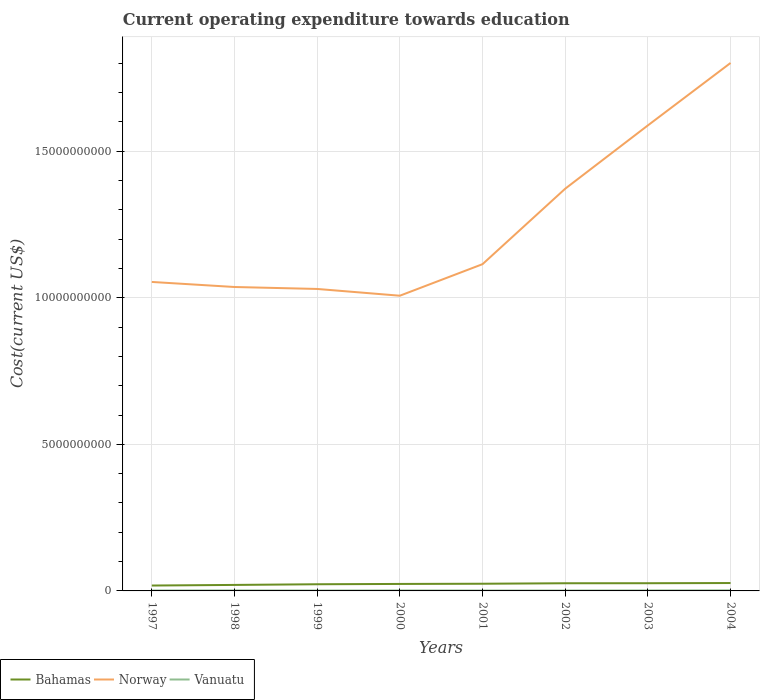Across all years, what is the maximum expenditure towards education in Norway?
Make the answer very short. 1.01e+1. In which year was the expenditure towards education in Bahamas maximum?
Offer a very short reply. 1997. What is the total expenditure towards education in Bahamas in the graph?
Ensure brevity in your answer.  -5.47e+07. What is the difference between the highest and the second highest expenditure towards education in Vanuatu?
Offer a terse response. 5.48e+06. Is the expenditure towards education in Bahamas strictly greater than the expenditure towards education in Norway over the years?
Your answer should be very brief. Yes. How many years are there in the graph?
Your answer should be compact. 8. Does the graph contain grids?
Your answer should be compact. Yes. Where does the legend appear in the graph?
Give a very brief answer. Bottom left. How many legend labels are there?
Make the answer very short. 3. What is the title of the graph?
Give a very brief answer. Current operating expenditure towards education. Does "Mali" appear as one of the legend labels in the graph?
Keep it short and to the point. No. What is the label or title of the Y-axis?
Ensure brevity in your answer.  Cost(current US$). What is the Cost(current US$) in Bahamas in 1997?
Your response must be concise. 1.84e+08. What is the Cost(current US$) in Norway in 1997?
Keep it short and to the point. 1.05e+1. What is the Cost(current US$) of Vanuatu in 1997?
Your answer should be very brief. 1.43e+07. What is the Cost(current US$) of Bahamas in 1998?
Provide a succinct answer. 2.04e+08. What is the Cost(current US$) in Norway in 1998?
Give a very brief answer. 1.04e+1. What is the Cost(current US$) in Vanuatu in 1998?
Keep it short and to the point. 1.70e+07. What is the Cost(current US$) of Bahamas in 1999?
Offer a terse response. 2.27e+08. What is the Cost(current US$) of Norway in 1999?
Offer a terse response. 1.03e+1. What is the Cost(current US$) of Vanuatu in 1999?
Your response must be concise. 1.39e+07. What is the Cost(current US$) of Bahamas in 2000?
Your answer should be very brief. 2.38e+08. What is the Cost(current US$) of Norway in 2000?
Ensure brevity in your answer.  1.01e+1. What is the Cost(current US$) of Vanuatu in 2000?
Make the answer very short. 1.58e+07. What is the Cost(current US$) of Bahamas in 2001?
Your response must be concise. 2.45e+08. What is the Cost(current US$) of Norway in 2001?
Provide a short and direct response. 1.11e+1. What is the Cost(current US$) of Vanuatu in 2001?
Give a very brief answer. 1.37e+07. What is the Cost(current US$) of Bahamas in 2002?
Offer a very short reply. 2.62e+08. What is the Cost(current US$) in Norway in 2002?
Offer a very short reply. 1.37e+1. What is the Cost(current US$) in Vanuatu in 2002?
Your answer should be compact. 1.37e+07. What is the Cost(current US$) of Bahamas in 2003?
Provide a succinct answer. 2.63e+08. What is the Cost(current US$) of Norway in 2003?
Offer a very short reply. 1.59e+1. What is the Cost(current US$) of Vanuatu in 2003?
Make the answer very short. 1.64e+07. What is the Cost(current US$) in Bahamas in 2004?
Make the answer very short. 2.69e+08. What is the Cost(current US$) in Norway in 2004?
Provide a short and direct response. 1.80e+1. What is the Cost(current US$) of Vanuatu in 2004?
Your answer should be compact. 1.91e+07. Across all years, what is the maximum Cost(current US$) in Bahamas?
Your response must be concise. 2.69e+08. Across all years, what is the maximum Cost(current US$) of Norway?
Offer a terse response. 1.80e+1. Across all years, what is the maximum Cost(current US$) of Vanuatu?
Ensure brevity in your answer.  1.91e+07. Across all years, what is the minimum Cost(current US$) in Bahamas?
Provide a short and direct response. 1.84e+08. Across all years, what is the minimum Cost(current US$) in Norway?
Provide a succinct answer. 1.01e+1. Across all years, what is the minimum Cost(current US$) in Vanuatu?
Make the answer very short. 1.37e+07. What is the total Cost(current US$) in Bahamas in the graph?
Ensure brevity in your answer.  1.89e+09. What is the total Cost(current US$) of Norway in the graph?
Keep it short and to the point. 1.00e+11. What is the total Cost(current US$) in Vanuatu in the graph?
Give a very brief answer. 1.24e+08. What is the difference between the Cost(current US$) of Bahamas in 1997 and that in 1998?
Provide a short and direct response. -2.07e+07. What is the difference between the Cost(current US$) in Norway in 1997 and that in 1998?
Offer a very short reply. 1.73e+08. What is the difference between the Cost(current US$) in Vanuatu in 1997 and that in 1998?
Ensure brevity in your answer.  -2.72e+06. What is the difference between the Cost(current US$) of Bahamas in 1997 and that in 1999?
Give a very brief answer. -4.37e+07. What is the difference between the Cost(current US$) of Norway in 1997 and that in 1999?
Give a very brief answer. 2.39e+08. What is the difference between the Cost(current US$) in Vanuatu in 1997 and that in 1999?
Your response must be concise. 3.95e+05. What is the difference between the Cost(current US$) in Bahamas in 1997 and that in 2000?
Your answer should be very brief. -5.47e+07. What is the difference between the Cost(current US$) of Norway in 1997 and that in 2000?
Make the answer very short. 4.70e+08. What is the difference between the Cost(current US$) in Vanuatu in 1997 and that in 2000?
Your answer should be very brief. -1.47e+06. What is the difference between the Cost(current US$) in Bahamas in 1997 and that in 2001?
Your answer should be compact. -6.13e+07. What is the difference between the Cost(current US$) of Norway in 1997 and that in 2001?
Your answer should be very brief. -6.06e+08. What is the difference between the Cost(current US$) in Vanuatu in 1997 and that in 2001?
Offer a very short reply. 6.16e+05. What is the difference between the Cost(current US$) of Bahamas in 1997 and that in 2002?
Ensure brevity in your answer.  -7.80e+07. What is the difference between the Cost(current US$) of Norway in 1997 and that in 2002?
Your answer should be compact. -3.18e+09. What is the difference between the Cost(current US$) of Vanuatu in 1997 and that in 2002?
Give a very brief answer. 6.63e+05. What is the difference between the Cost(current US$) in Bahamas in 1997 and that in 2003?
Give a very brief answer. -7.91e+07. What is the difference between the Cost(current US$) in Norway in 1997 and that in 2003?
Give a very brief answer. -5.34e+09. What is the difference between the Cost(current US$) in Vanuatu in 1997 and that in 2003?
Your answer should be very brief. -2.09e+06. What is the difference between the Cost(current US$) of Bahamas in 1997 and that in 2004?
Your response must be concise. -8.54e+07. What is the difference between the Cost(current US$) in Norway in 1997 and that in 2004?
Keep it short and to the point. -7.47e+09. What is the difference between the Cost(current US$) of Vanuatu in 1997 and that in 2004?
Give a very brief answer. -4.82e+06. What is the difference between the Cost(current US$) of Bahamas in 1998 and that in 1999?
Ensure brevity in your answer.  -2.30e+07. What is the difference between the Cost(current US$) in Norway in 1998 and that in 1999?
Make the answer very short. 6.64e+07. What is the difference between the Cost(current US$) of Vanuatu in 1998 and that in 1999?
Offer a very short reply. 3.12e+06. What is the difference between the Cost(current US$) in Bahamas in 1998 and that in 2000?
Give a very brief answer. -3.40e+07. What is the difference between the Cost(current US$) in Norway in 1998 and that in 2000?
Give a very brief answer. 2.97e+08. What is the difference between the Cost(current US$) in Vanuatu in 1998 and that in 2000?
Your answer should be very brief. 1.25e+06. What is the difference between the Cost(current US$) in Bahamas in 1998 and that in 2001?
Provide a succinct answer. -4.06e+07. What is the difference between the Cost(current US$) in Norway in 1998 and that in 2001?
Keep it short and to the point. -7.79e+08. What is the difference between the Cost(current US$) of Vanuatu in 1998 and that in 2001?
Keep it short and to the point. 3.34e+06. What is the difference between the Cost(current US$) of Bahamas in 1998 and that in 2002?
Keep it short and to the point. -5.72e+07. What is the difference between the Cost(current US$) in Norway in 1998 and that in 2002?
Offer a terse response. -3.35e+09. What is the difference between the Cost(current US$) of Vanuatu in 1998 and that in 2002?
Make the answer very short. 3.38e+06. What is the difference between the Cost(current US$) in Bahamas in 1998 and that in 2003?
Ensure brevity in your answer.  -5.84e+07. What is the difference between the Cost(current US$) of Norway in 1998 and that in 2003?
Keep it short and to the point. -5.51e+09. What is the difference between the Cost(current US$) of Vanuatu in 1998 and that in 2003?
Ensure brevity in your answer.  6.31e+05. What is the difference between the Cost(current US$) of Bahamas in 1998 and that in 2004?
Provide a short and direct response. -6.46e+07. What is the difference between the Cost(current US$) in Norway in 1998 and that in 2004?
Make the answer very short. -7.64e+09. What is the difference between the Cost(current US$) in Vanuatu in 1998 and that in 2004?
Your answer should be very brief. -2.10e+06. What is the difference between the Cost(current US$) in Bahamas in 1999 and that in 2000?
Ensure brevity in your answer.  -1.10e+07. What is the difference between the Cost(current US$) of Norway in 1999 and that in 2000?
Ensure brevity in your answer.  2.31e+08. What is the difference between the Cost(current US$) in Vanuatu in 1999 and that in 2000?
Offer a very short reply. -1.87e+06. What is the difference between the Cost(current US$) in Bahamas in 1999 and that in 2001?
Ensure brevity in your answer.  -1.75e+07. What is the difference between the Cost(current US$) in Norway in 1999 and that in 2001?
Ensure brevity in your answer.  -8.45e+08. What is the difference between the Cost(current US$) in Vanuatu in 1999 and that in 2001?
Your response must be concise. 2.22e+05. What is the difference between the Cost(current US$) of Bahamas in 1999 and that in 2002?
Provide a succinct answer. -3.42e+07. What is the difference between the Cost(current US$) in Norway in 1999 and that in 2002?
Give a very brief answer. -3.42e+09. What is the difference between the Cost(current US$) of Vanuatu in 1999 and that in 2002?
Give a very brief answer. 2.68e+05. What is the difference between the Cost(current US$) in Bahamas in 1999 and that in 2003?
Your response must be concise. -3.54e+07. What is the difference between the Cost(current US$) in Norway in 1999 and that in 2003?
Your answer should be compact. -5.58e+09. What is the difference between the Cost(current US$) of Vanuatu in 1999 and that in 2003?
Offer a terse response. -2.48e+06. What is the difference between the Cost(current US$) in Bahamas in 1999 and that in 2004?
Your answer should be very brief. -4.16e+07. What is the difference between the Cost(current US$) in Norway in 1999 and that in 2004?
Keep it short and to the point. -7.71e+09. What is the difference between the Cost(current US$) in Vanuatu in 1999 and that in 2004?
Your response must be concise. -5.21e+06. What is the difference between the Cost(current US$) of Bahamas in 2000 and that in 2001?
Ensure brevity in your answer.  -6.59e+06. What is the difference between the Cost(current US$) of Norway in 2000 and that in 2001?
Make the answer very short. -1.08e+09. What is the difference between the Cost(current US$) in Vanuatu in 2000 and that in 2001?
Keep it short and to the point. 2.09e+06. What is the difference between the Cost(current US$) of Bahamas in 2000 and that in 2002?
Offer a terse response. -2.33e+07. What is the difference between the Cost(current US$) of Norway in 2000 and that in 2002?
Provide a short and direct response. -3.65e+09. What is the difference between the Cost(current US$) in Vanuatu in 2000 and that in 2002?
Provide a succinct answer. 2.13e+06. What is the difference between the Cost(current US$) in Bahamas in 2000 and that in 2003?
Provide a succinct answer. -2.44e+07. What is the difference between the Cost(current US$) of Norway in 2000 and that in 2003?
Provide a short and direct response. -5.81e+09. What is the difference between the Cost(current US$) in Vanuatu in 2000 and that in 2003?
Give a very brief answer. -6.18e+05. What is the difference between the Cost(current US$) in Bahamas in 2000 and that in 2004?
Offer a very short reply. -3.07e+07. What is the difference between the Cost(current US$) of Norway in 2000 and that in 2004?
Offer a terse response. -7.94e+09. What is the difference between the Cost(current US$) of Vanuatu in 2000 and that in 2004?
Offer a very short reply. -3.35e+06. What is the difference between the Cost(current US$) in Bahamas in 2001 and that in 2002?
Your response must be concise. -1.67e+07. What is the difference between the Cost(current US$) in Norway in 2001 and that in 2002?
Offer a terse response. -2.57e+09. What is the difference between the Cost(current US$) of Vanuatu in 2001 and that in 2002?
Your response must be concise. 4.61e+04. What is the difference between the Cost(current US$) of Bahamas in 2001 and that in 2003?
Make the answer very short. -1.78e+07. What is the difference between the Cost(current US$) of Norway in 2001 and that in 2003?
Provide a succinct answer. -4.73e+09. What is the difference between the Cost(current US$) of Vanuatu in 2001 and that in 2003?
Give a very brief answer. -2.71e+06. What is the difference between the Cost(current US$) in Bahamas in 2001 and that in 2004?
Offer a very short reply. -2.41e+07. What is the difference between the Cost(current US$) in Norway in 2001 and that in 2004?
Keep it short and to the point. -6.86e+09. What is the difference between the Cost(current US$) in Vanuatu in 2001 and that in 2004?
Keep it short and to the point. -5.44e+06. What is the difference between the Cost(current US$) in Bahamas in 2002 and that in 2003?
Your answer should be compact. -1.14e+06. What is the difference between the Cost(current US$) in Norway in 2002 and that in 2003?
Keep it short and to the point. -2.16e+09. What is the difference between the Cost(current US$) in Vanuatu in 2002 and that in 2003?
Keep it short and to the point. -2.75e+06. What is the difference between the Cost(current US$) of Bahamas in 2002 and that in 2004?
Offer a terse response. -7.40e+06. What is the difference between the Cost(current US$) in Norway in 2002 and that in 2004?
Keep it short and to the point. -4.29e+09. What is the difference between the Cost(current US$) of Vanuatu in 2002 and that in 2004?
Your answer should be very brief. -5.48e+06. What is the difference between the Cost(current US$) of Bahamas in 2003 and that in 2004?
Offer a terse response. -6.26e+06. What is the difference between the Cost(current US$) of Norway in 2003 and that in 2004?
Ensure brevity in your answer.  -2.13e+09. What is the difference between the Cost(current US$) in Vanuatu in 2003 and that in 2004?
Offer a terse response. -2.73e+06. What is the difference between the Cost(current US$) in Bahamas in 1997 and the Cost(current US$) in Norway in 1998?
Give a very brief answer. -1.02e+1. What is the difference between the Cost(current US$) of Bahamas in 1997 and the Cost(current US$) of Vanuatu in 1998?
Offer a terse response. 1.67e+08. What is the difference between the Cost(current US$) of Norway in 1997 and the Cost(current US$) of Vanuatu in 1998?
Your answer should be compact. 1.05e+1. What is the difference between the Cost(current US$) of Bahamas in 1997 and the Cost(current US$) of Norway in 1999?
Give a very brief answer. -1.01e+1. What is the difference between the Cost(current US$) in Bahamas in 1997 and the Cost(current US$) in Vanuatu in 1999?
Provide a short and direct response. 1.70e+08. What is the difference between the Cost(current US$) in Norway in 1997 and the Cost(current US$) in Vanuatu in 1999?
Make the answer very short. 1.05e+1. What is the difference between the Cost(current US$) of Bahamas in 1997 and the Cost(current US$) of Norway in 2000?
Your answer should be compact. -9.89e+09. What is the difference between the Cost(current US$) of Bahamas in 1997 and the Cost(current US$) of Vanuatu in 2000?
Provide a succinct answer. 1.68e+08. What is the difference between the Cost(current US$) of Norway in 1997 and the Cost(current US$) of Vanuatu in 2000?
Keep it short and to the point. 1.05e+1. What is the difference between the Cost(current US$) of Bahamas in 1997 and the Cost(current US$) of Norway in 2001?
Make the answer very short. -1.10e+1. What is the difference between the Cost(current US$) in Bahamas in 1997 and the Cost(current US$) in Vanuatu in 2001?
Your answer should be compact. 1.70e+08. What is the difference between the Cost(current US$) of Norway in 1997 and the Cost(current US$) of Vanuatu in 2001?
Offer a terse response. 1.05e+1. What is the difference between the Cost(current US$) of Bahamas in 1997 and the Cost(current US$) of Norway in 2002?
Keep it short and to the point. -1.35e+1. What is the difference between the Cost(current US$) in Bahamas in 1997 and the Cost(current US$) in Vanuatu in 2002?
Provide a succinct answer. 1.70e+08. What is the difference between the Cost(current US$) in Norway in 1997 and the Cost(current US$) in Vanuatu in 2002?
Give a very brief answer. 1.05e+1. What is the difference between the Cost(current US$) in Bahamas in 1997 and the Cost(current US$) in Norway in 2003?
Your response must be concise. -1.57e+1. What is the difference between the Cost(current US$) in Bahamas in 1997 and the Cost(current US$) in Vanuatu in 2003?
Your answer should be very brief. 1.67e+08. What is the difference between the Cost(current US$) of Norway in 1997 and the Cost(current US$) of Vanuatu in 2003?
Provide a short and direct response. 1.05e+1. What is the difference between the Cost(current US$) in Bahamas in 1997 and the Cost(current US$) in Norway in 2004?
Ensure brevity in your answer.  -1.78e+1. What is the difference between the Cost(current US$) in Bahamas in 1997 and the Cost(current US$) in Vanuatu in 2004?
Keep it short and to the point. 1.65e+08. What is the difference between the Cost(current US$) of Norway in 1997 and the Cost(current US$) of Vanuatu in 2004?
Provide a succinct answer. 1.05e+1. What is the difference between the Cost(current US$) of Bahamas in 1998 and the Cost(current US$) of Norway in 1999?
Keep it short and to the point. -1.01e+1. What is the difference between the Cost(current US$) in Bahamas in 1998 and the Cost(current US$) in Vanuatu in 1999?
Offer a terse response. 1.91e+08. What is the difference between the Cost(current US$) of Norway in 1998 and the Cost(current US$) of Vanuatu in 1999?
Make the answer very short. 1.04e+1. What is the difference between the Cost(current US$) in Bahamas in 1998 and the Cost(current US$) in Norway in 2000?
Offer a terse response. -9.87e+09. What is the difference between the Cost(current US$) of Bahamas in 1998 and the Cost(current US$) of Vanuatu in 2000?
Offer a terse response. 1.89e+08. What is the difference between the Cost(current US$) in Norway in 1998 and the Cost(current US$) in Vanuatu in 2000?
Offer a terse response. 1.04e+1. What is the difference between the Cost(current US$) in Bahamas in 1998 and the Cost(current US$) in Norway in 2001?
Your answer should be compact. -1.09e+1. What is the difference between the Cost(current US$) in Bahamas in 1998 and the Cost(current US$) in Vanuatu in 2001?
Ensure brevity in your answer.  1.91e+08. What is the difference between the Cost(current US$) of Norway in 1998 and the Cost(current US$) of Vanuatu in 2001?
Your answer should be very brief. 1.04e+1. What is the difference between the Cost(current US$) in Bahamas in 1998 and the Cost(current US$) in Norway in 2002?
Offer a very short reply. -1.35e+1. What is the difference between the Cost(current US$) of Bahamas in 1998 and the Cost(current US$) of Vanuatu in 2002?
Make the answer very short. 1.91e+08. What is the difference between the Cost(current US$) in Norway in 1998 and the Cost(current US$) in Vanuatu in 2002?
Provide a succinct answer. 1.04e+1. What is the difference between the Cost(current US$) of Bahamas in 1998 and the Cost(current US$) of Norway in 2003?
Your answer should be very brief. -1.57e+1. What is the difference between the Cost(current US$) of Bahamas in 1998 and the Cost(current US$) of Vanuatu in 2003?
Give a very brief answer. 1.88e+08. What is the difference between the Cost(current US$) of Norway in 1998 and the Cost(current US$) of Vanuatu in 2003?
Provide a short and direct response. 1.04e+1. What is the difference between the Cost(current US$) in Bahamas in 1998 and the Cost(current US$) in Norway in 2004?
Ensure brevity in your answer.  -1.78e+1. What is the difference between the Cost(current US$) of Bahamas in 1998 and the Cost(current US$) of Vanuatu in 2004?
Make the answer very short. 1.85e+08. What is the difference between the Cost(current US$) of Norway in 1998 and the Cost(current US$) of Vanuatu in 2004?
Provide a succinct answer. 1.03e+1. What is the difference between the Cost(current US$) in Bahamas in 1999 and the Cost(current US$) in Norway in 2000?
Keep it short and to the point. -9.84e+09. What is the difference between the Cost(current US$) of Bahamas in 1999 and the Cost(current US$) of Vanuatu in 2000?
Your answer should be compact. 2.12e+08. What is the difference between the Cost(current US$) of Norway in 1999 and the Cost(current US$) of Vanuatu in 2000?
Your response must be concise. 1.03e+1. What is the difference between the Cost(current US$) of Bahamas in 1999 and the Cost(current US$) of Norway in 2001?
Give a very brief answer. -1.09e+1. What is the difference between the Cost(current US$) of Bahamas in 1999 and the Cost(current US$) of Vanuatu in 2001?
Offer a very short reply. 2.14e+08. What is the difference between the Cost(current US$) in Norway in 1999 and the Cost(current US$) in Vanuatu in 2001?
Your response must be concise. 1.03e+1. What is the difference between the Cost(current US$) of Bahamas in 1999 and the Cost(current US$) of Norway in 2002?
Keep it short and to the point. -1.35e+1. What is the difference between the Cost(current US$) of Bahamas in 1999 and the Cost(current US$) of Vanuatu in 2002?
Your response must be concise. 2.14e+08. What is the difference between the Cost(current US$) in Norway in 1999 and the Cost(current US$) in Vanuatu in 2002?
Make the answer very short. 1.03e+1. What is the difference between the Cost(current US$) in Bahamas in 1999 and the Cost(current US$) in Norway in 2003?
Your answer should be very brief. -1.57e+1. What is the difference between the Cost(current US$) of Bahamas in 1999 and the Cost(current US$) of Vanuatu in 2003?
Make the answer very short. 2.11e+08. What is the difference between the Cost(current US$) in Norway in 1999 and the Cost(current US$) in Vanuatu in 2003?
Give a very brief answer. 1.03e+1. What is the difference between the Cost(current US$) of Bahamas in 1999 and the Cost(current US$) of Norway in 2004?
Your response must be concise. -1.78e+1. What is the difference between the Cost(current US$) of Bahamas in 1999 and the Cost(current US$) of Vanuatu in 2004?
Keep it short and to the point. 2.08e+08. What is the difference between the Cost(current US$) in Norway in 1999 and the Cost(current US$) in Vanuatu in 2004?
Give a very brief answer. 1.03e+1. What is the difference between the Cost(current US$) in Bahamas in 2000 and the Cost(current US$) in Norway in 2001?
Keep it short and to the point. -1.09e+1. What is the difference between the Cost(current US$) in Bahamas in 2000 and the Cost(current US$) in Vanuatu in 2001?
Keep it short and to the point. 2.25e+08. What is the difference between the Cost(current US$) of Norway in 2000 and the Cost(current US$) of Vanuatu in 2001?
Offer a very short reply. 1.01e+1. What is the difference between the Cost(current US$) of Bahamas in 2000 and the Cost(current US$) of Norway in 2002?
Give a very brief answer. -1.35e+1. What is the difference between the Cost(current US$) of Bahamas in 2000 and the Cost(current US$) of Vanuatu in 2002?
Make the answer very short. 2.25e+08. What is the difference between the Cost(current US$) in Norway in 2000 and the Cost(current US$) in Vanuatu in 2002?
Your response must be concise. 1.01e+1. What is the difference between the Cost(current US$) of Bahamas in 2000 and the Cost(current US$) of Norway in 2003?
Your answer should be very brief. -1.56e+1. What is the difference between the Cost(current US$) in Bahamas in 2000 and the Cost(current US$) in Vanuatu in 2003?
Your response must be concise. 2.22e+08. What is the difference between the Cost(current US$) of Norway in 2000 and the Cost(current US$) of Vanuatu in 2003?
Ensure brevity in your answer.  1.01e+1. What is the difference between the Cost(current US$) of Bahamas in 2000 and the Cost(current US$) of Norway in 2004?
Keep it short and to the point. -1.78e+1. What is the difference between the Cost(current US$) of Bahamas in 2000 and the Cost(current US$) of Vanuatu in 2004?
Your response must be concise. 2.19e+08. What is the difference between the Cost(current US$) in Norway in 2000 and the Cost(current US$) in Vanuatu in 2004?
Offer a terse response. 1.01e+1. What is the difference between the Cost(current US$) in Bahamas in 2001 and the Cost(current US$) in Norway in 2002?
Provide a succinct answer. -1.35e+1. What is the difference between the Cost(current US$) of Bahamas in 2001 and the Cost(current US$) of Vanuatu in 2002?
Provide a succinct answer. 2.31e+08. What is the difference between the Cost(current US$) of Norway in 2001 and the Cost(current US$) of Vanuatu in 2002?
Keep it short and to the point. 1.11e+1. What is the difference between the Cost(current US$) of Bahamas in 2001 and the Cost(current US$) of Norway in 2003?
Offer a terse response. -1.56e+1. What is the difference between the Cost(current US$) in Bahamas in 2001 and the Cost(current US$) in Vanuatu in 2003?
Offer a terse response. 2.29e+08. What is the difference between the Cost(current US$) of Norway in 2001 and the Cost(current US$) of Vanuatu in 2003?
Make the answer very short. 1.11e+1. What is the difference between the Cost(current US$) in Bahamas in 2001 and the Cost(current US$) in Norway in 2004?
Provide a succinct answer. -1.78e+1. What is the difference between the Cost(current US$) of Bahamas in 2001 and the Cost(current US$) of Vanuatu in 2004?
Provide a succinct answer. 2.26e+08. What is the difference between the Cost(current US$) of Norway in 2001 and the Cost(current US$) of Vanuatu in 2004?
Provide a short and direct response. 1.11e+1. What is the difference between the Cost(current US$) of Bahamas in 2002 and the Cost(current US$) of Norway in 2003?
Make the answer very short. -1.56e+1. What is the difference between the Cost(current US$) in Bahamas in 2002 and the Cost(current US$) in Vanuatu in 2003?
Offer a very short reply. 2.45e+08. What is the difference between the Cost(current US$) of Norway in 2002 and the Cost(current US$) of Vanuatu in 2003?
Your answer should be compact. 1.37e+1. What is the difference between the Cost(current US$) in Bahamas in 2002 and the Cost(current US$) in Norway in 2004?
Give a very brief answer. -1.77e+1. What is the difference between the Cost(current US$) in Bahamas in 2002 and the Cost(current US$) in Vanuatu in 2004?
Ensure brevity in your answer.  2.43e+08. What is the difference between the Cost(current US$) in Norway in 2002 and the Cost(current US$) in Vanuatu in 2004?
Your answer should be very brief. 1.37e+1. What is the difference between the Cost(current US$) of Bahamas in 2003 and the Cost(current US$) of Norway in 2004?
Ensure brevity in your answer.  -1.77e+1. What is the difference between the Cost(current US$) of Bahamas in 2003 and the Cost(current US$) of Vanuatu in 2004?
Offer a very short reply. 2.44e+08. What is the difference between the Cost(current US$) in Norway in 2003 and the Cost(current US$) in Vanuatu in 2004?
Your response must be concise. 1.59e+1. What is the average Cost(current US$) of Bahamas per year?
Your answer should be compact. 2.37e+08. What is the average Cost(current US$) of Norway per year?
Offer a very short reply. 1.25e+1. What is the average Cost(current US$) of Vanuatu per year?
Your response must be concise. 1.55e+07. In the year 1997, what is the difference between the Cost(current US$) in Bahamas and Cost(current US$) in Norway?
Provide a succinct answer. -1.04e+1. In the year 1997, what is the difference between the Cost(current US$) in Bahamas and Cost(current US$) in Vanuatu?
Your answer should be compact. 1.69e+08. In the year 1997, what is the difference between the Cost(current US$) in Norway and Cost(current US$) in Vanuatu?
Your answer should be compact. 1.05e+1. In the year 1998, what is the difference between the Cost(current US$) of Bahamas and Cost(current US$) of Norway?
Ensure brevity in your answer.  -1.02e+1. In the year 1998, what is the difference between the Cost(current US$) in Bahamas and Cost(current US$) in Vanuatu?
Your answer should be very brief. 1.87e+08. In the year 1998, what is the difference between the Cost(current US$) in Norway and Cost(current US$) in Vanuatu?
Provide a short and direct response. 1.04e+1. In the year 1999, what is the difference between the Cost(current US$) of Bahamas and Cost(current US$) of Norway?
Keep it short and to the point. -1.01e+1. In the year 1999, what is the difference between the Cost(current US$) in Bahamas and Cost(current US$) in Vanuatu?
Your answer should be compact. 2.14e+08. In the year 1999, what is the difference between the Cost(current US$) in Norway and Cost(current US$) in Vanuatu?
Provide a succinct answer. 1.03e+1. In the year 2000, what is the difference between the Cost(current US$) of Bahamas and Cost(current US$) of Norway?
Give a very brief answer. -9.83e+09. In the year 2000, what is the difference between the Cost(current US$) in Bahamas and Cost(current US$) in Vanuatu?
Give a very brief answer. 2.23e+08. In the year 2000, what is the difference between the Cost(current US$) in Norway and Cost(current US$) in Vanuatu?
Offer a terse response. 1.01e+1. In the year 2001, what is the difference between the Cost(current US$) of Bahamas and Cost(current US$) of Norway?
Provide a succinct answer. -1.09e+1. In the year 2001, what is the difference between the Cost(current US$) in Bahamas and Cost(current US$) in Vanuatu?
Your answer should be very brief. 2.31e+08. In the year 2001, what is the difference between the Cost(current US$) in Norway and Cost(current US$) in Vanuatu?
Ensure brevity in your answer.  1.11e+1. In the year 2002, what is the difference between the Cost(current US$) in Bahamas and Cost(current US$) in Norway?
Provide a short and direct response. -1.35e+1. In the year 2002, what is the difference between the Cost(current US$) of Bahamas and Cost(current US$) of Vanuatu?
Provide a succinct answer. 2.48e+08. In the year 2002, what is the difference between the Cost(current US$) of Norway and Cost(current US$) of Vanuatu?
Provide a succinct answer. 1.37e+1. In the year 2003, what is the difference between the Cost(current US$) of Bahamas and Cost(current US$) of Norway?
Offer a very short reply. -1.56e+1. In the year 2003, what is the difference between the Cost(current US$) of Bahamas and Cost(current US$) of Vanuatu?
Your answer should be compact. 2.46e+08. In the year 2003, what is the difference between the Cost(current US$) of Norway and Cost(current US$) of Vanuatu?
Give a very brief answer. 1.59e+1. In the year 2004, what is the difference between the Cost(current US$) in Bahamas and Cost(current US$) in Norway?
Make the answer very short. -1.77e+1. In the year 2004, what is the difference between the Cost(current US$) in Bahamas and Cost(current US$) in Vanuatu?
Offer a terse response. 2.50e+08. In the year 2004, what is the difference between the Cost(current US$) of Norway and Cost(current US$) of Vanuatu?
Provide a short and direct response. 1.80e+1. What is the ratio of the Cost(current US$) in Bahamas in 1997 to that in 1998?
Your response must be concise. 0.9. What is the ratio of the Cost(current US$) in Norway in 1997 to that in 1998?
Give a very brief answer. 1.02. What is the ratio of the Cost(current US$) in Vanuatu in 1997 to that in 1998?
Your answer should be compact. 0.84. What is the ratio of the Cost(current US$) in Bahamas in 1997 to that in 1999?
Your answer should be very brief. 0.81. What is the ratio of the Cost(current US$) in Norway in 1997 to that in 1999?
Give a very brief answer. 1.02. What is the ratio of the Cost(current US$) in Vanuatu in 1997 to that in 1999?
Offer a terse response. 1.03. What is the ratio of the Cost(current US$) of Bahamas in 1997 to that in 2000?
Offer a very short reply. 0.77. What is the ratio of the Cost(current US$) in Norway in 1997 to that in 2000?
Ensure brevity in your answer.  1.05. What is the ratio of the Cost(current US$) of Vanuatu in 1997 to that in 2000?
Provide a short and direct response. 0.91. What is the ratio of the Cost(current US$) in Bahamas in 1997 to that in 2001?
Provide a short and direct response. 0.75. What is the ratio of the Cost(current US$) of Norway in 1997 to that in 2001?
Provide a short and direct response. 0.95. What is the ratio of the Cost(current US$) in Vanuatu in 1997 to that in 2001?
Provide a short and direct response. 1.04. What is the ratio of the Cost(current US$) of Bahamas in 1997 to that in 2002?
Offer a terse response. 0.7. What is the ratio of the Cost(current US$) in Norway in 1997 to that in 2002?
Your response must be concise. 0.77. What is the ratio of the Cost(current US$) of Vanuatu in 1997 to that in 2002?
Keep it short and to the point. 1.05. What is the ratio of the Cost(current US$) of Bahamas in 1997 to that in 2003?
Ensure brevity in your answer.  0.7. What is the ratio of the Cost(current US$) in Norway in 1997 to that in 2003?
Keep it short and to the point. 0.66. What is the ratio of the Cost(current US$) in Vanuatu in 1997 to that in 2003?
Offer a very short reply. 0.87. What is the ratio of the Cost(current US$) of Bahamas in 1997 to that in 2004?
Offer a very short reply. 0.68. What is the ratio of the Cost(current US$) of Norway in 1997 to that in 2004?
Your answer should be very brief. 0.59. What is the ratio of the Cost(current US$) in Vanuatu in 1997 to that in 2004?
Keep it short and to the point. 0.75. What is the ratio of the Cost(current US$) in Bahamas in 1998 to that in 1999?
Your answer should be very brief. 0.9. What is the ratio of the Cost(current US$) in Norway in 1998 to that in 1999?
Your response must be concise. 1.01. What is the ratio of the Cost(current US$) in Vanuatu in 1998 to that in 1999?
Make the answer very short. 1.22. What is the ratio of the Cost(current US$) in Bahamas in 1998 to that in 2000?
Offer a very short reply. 0.86. What is the ratio of the Cost(current US$) in Norway in 1998 to that in 2000?
Your answer should be very brief. 1.03. What is the ratio of the Cost(current US$) in Vanuatu in 1998 to that in 2000?
Your answer should be very brief. 1.08. What is the ratio of the Cost(current US$) in Bahamas in 1998 to that in 2001?
Your answer should be compact. 0.83. What is the ratio of the Cost(current US$) in Norway in 1998 to that in 2001?
Provide a succinct answer. 0.93. What is the ratio of the Cost(current US$) in Vanuatu in 1998 to that in 2001?
Keep it short and to the point. 1.24. What is the ratio of the Cost(current US$) of Bahamas in 1998 to that in 2002?
Offer a very short reply. 0.78. What is the ratio of the Cost(current US$) in Norway in 1998 to that in 2002?
Offer a very short reply. 0.76. What is the ratio of the Cost(current US$) of Vanuatu in 1998 to that in 2002?
Your answer should be compact. 1.25. What is the ratio of the Cost(current US$) of Bahamas in 1998 to that in 2003?
Offer a terse response. 0.78. What is the ratio of the Cost(current US$) in Norway in 1998 to that in 2003?
Your answer should be very brief. 0.65. What is the ratio of the Cost(current US$) in Vanuatu in 1998 to that in 2003?
Give a very brief answer. 1.04. What is the ratio of the Cost(current US$) of Bahamas in 1998 to that in 2004?
Keep it short and to the point. 0.76. What is the ratio of the Cost(current US$) of Norway in 1998 to that in 2004?
Your answer should be very brief. 0.58. What is the ratio of the Cost(current US$) in Vanuatu in 1998 to that in 2004?
Your answer should be compact. 0.89. What is the ratio of the Cost(current US$) of Bahamas in 1999 to that in 2000?
Your answer should be compact. 0.95. What is the ratio of the Cost(current US$) in Norway in 1999 to that in 2000?
Ensure brevity in your answer.  1.02. What is the ratio of the Cost(current US$) of Vanuatu in 1999 to that in 2000?
Offer a terse response. 0.88. What is the ratio of the Cost(current US$) in Bahamas in 1999 to that in 2001?
Give a very brief answer. 0.93. What is the ratio of the Cost(current US$) in Norway in 1999 to that in 2001?
Provide a short and direct response. 0.92. What is the ratio of the Cost(current US$) of Vanuatu in 1999 to that in 2001?
Ensure brevity in your answer.  1.02. What is the ratio of the Cost(current US$) of Bahamas in 1999 to that in 2002?
Ensure brevity in your answer.  0.87. What is the ratio of the Cost(current US$) in Norway in 1999 to that in 2002?
Your response must be concise. 0.75. What is the ratio of the Cost(current US$) of Vanuatu in 1999 to that in 2002?
Offer a very short reply. 1.02. What is the ratio of the Cost(current US$) of Bahamas in 1999 to that in 2003?
Offer a very short reply. 0.87. What is the ratio of the Cost(current US$) of Norway in 1999 to that in 2003?
Ensure brevity in your answer.  0.65. What is the ratio of the Cost(current US$) of Vanuatu in 1999 to that in 2003?
Your response must be concise. 0.85. What is the ratio of the Cost(current US$) in Bahamas in 1999 to that in 2004?
Ensure brevity in your answer.  0.85. What is the ratio of the Cost(current US$) in Norway in 1999 to that in 2004?
Offer a terse response. 0.57. What is the ratio of the Cost(current US$) in Vanuatu in 1999 to that in 2004?
Your answer should be compact. 0.73. What is the ratio of the Cost(current US$) in Bahamas in 2000 to that in 2001?
Make the answer very short. 0.97. What is the ratio of the Cost(current US$) of Norway in 2000 to that in 2001?
Offer a very short reply. 0.9. What is the ratio of the Cost(current US$) of Vanuatu in 2000 to that in 2001?
Your answer should be very brief. 1.15. What is the ratio of the Cost(current US$) of Bahamas in 2000 to that in 2002?
Give a very brief answer. 0.91. What is the ratio of the Cost(current US$) in Norway in 2000 to that in 2002?
Your response must be concise. 0.73. What is the ratio of the Cost(current US$) in Vanuatu in 2000 to that in 2002?
Provide a succinct answer. 1.16. What is the ratio of the Cost(current US$) in Bahamas in 2000 to that in 2003?
Provide a short and direct response. 0.91. What is the ratio of the Cost(current US$) of Norway in 2000 to that in 2003?
Ensure brevity in your answer.  0.63. What is the ratio of the Cost(current US$) of Vanuatu in 2000 to that in 2003?
Offer a very short reply. 0.96. What is the ratio of the Cost(current US$) in Bahamas in 2000 to that in 2004?
Your response must be concise. 0.89. What is the ratio of the Cost(current US$) in Norway in 2000 to that in 2004?
Provide a succinct answer. 0.56. What is the ratio of the Cost(current US$) in Vanuatu in 2000 to that in 2004?
Provide a short and direct response. 0.83. What is the ratio of the Cost(current US$) in Bahamas in 2001 to that in 2002?
Offer a terse response. 0.94. What is the ratio of the Cost(current US$) in Norway in 2001 to that in 2002?
Offer a terse response. 0.81. What is the ratio of the Cost(current US$) in Bahamas in 2001 to that in 2003?
Your response must be concise. 0.93. What is the ratio of the Cost(current US$) of Norway in 2001 to that in 2003?
Keep it short and to the point. 0.7. What is the ratio of the Cost(current US$) in Vanuatu in 2001 to that in 2003?
Ensure brevity in your answer.  0.84. What is the ratio of the Cost(current US$) in Bahamas in 2001 to that in 2004?
Your response must be concise. 0.91. What is the ratio of the Cost(current US$) in Norway in 2001 to that in 2004?
Offer a terse response. 0.62. What is the ratio of the Cost(current US$) in Vanuatu in 2001 to that in 2004?
Give a very brief answer. 0.72. What is the ratio of the Cost(current US$) of Bahamas in 2002 to that in 2003?
Offer a very short reply. 1. What is the ratio of the Cost(current US$) in Norway in 2002 to that in 2003?
Give a very brief answer. 0.86. What is the ratio of the Cost(current US$) of Vanuatu in 2002 to that in 2003?
Offer a very short reply. 0.83. What is the ratio of the Cost(current US$) in Bahamas in 2002 to that in 2004?
Offer a terse response. 0.97. What is the ratio of the Cost(current US$) in Norway in 2002 to that in 2004?
Provide a succinct answer. 0.76. What is the ratio of the Cost(current US$) in Vanuatu in 2002 to that in 2004?
Offer a very short reply. 0.71. What is the ratio of the Cost(current US$) in Bahamas in 2003 to that in 2004?
Keep it short and to the point. 0.98. What is the ratio of the Cost(current US$) in Norway in 2003 to that in 2004?
Make the answer very short. 0.88. What is the ratio of the Cost(current US$) in Vanuatu in 2003 to that in 2004?
Provide a succinct answer. 0.86. What is the difference between the highest and the second highest Cost(current US$) in Bahamas?
Give a very brief answer. 6.26e+06. What is the difference between the highest and the second highest Cost(current US$) in Norway?
Your response must be concise. 2.13e+09. What is the difference between the highest and the second highest Cost(current US$) of Vanuatu?
Make the answer very short. 2.10e+06. What is the difference between the highest and the lowest Cost(current US$) of Bahamas?
Provide a short and direct response. 8.54e+07. What is the difference between the highest and the lowest Cost(current US$) in Norway?
Provide a succinct answer. 7.94e+09. What is the difference between the highest and the lowest Cost(current US$) of Vanuatu?
Keep it short and to the point. 5.48e+06. 